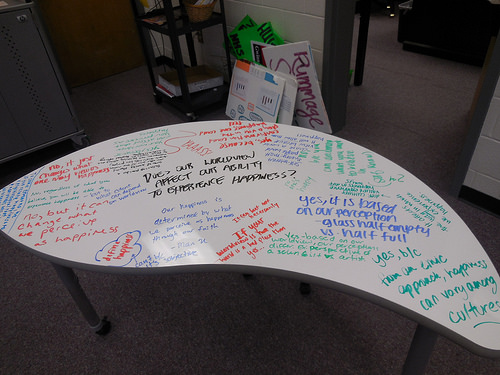<image>
Is there a writing in front of the cardboard? No. The writing is not in front of the cardboard. The spatial positioning shows a different relationship between these objects. 